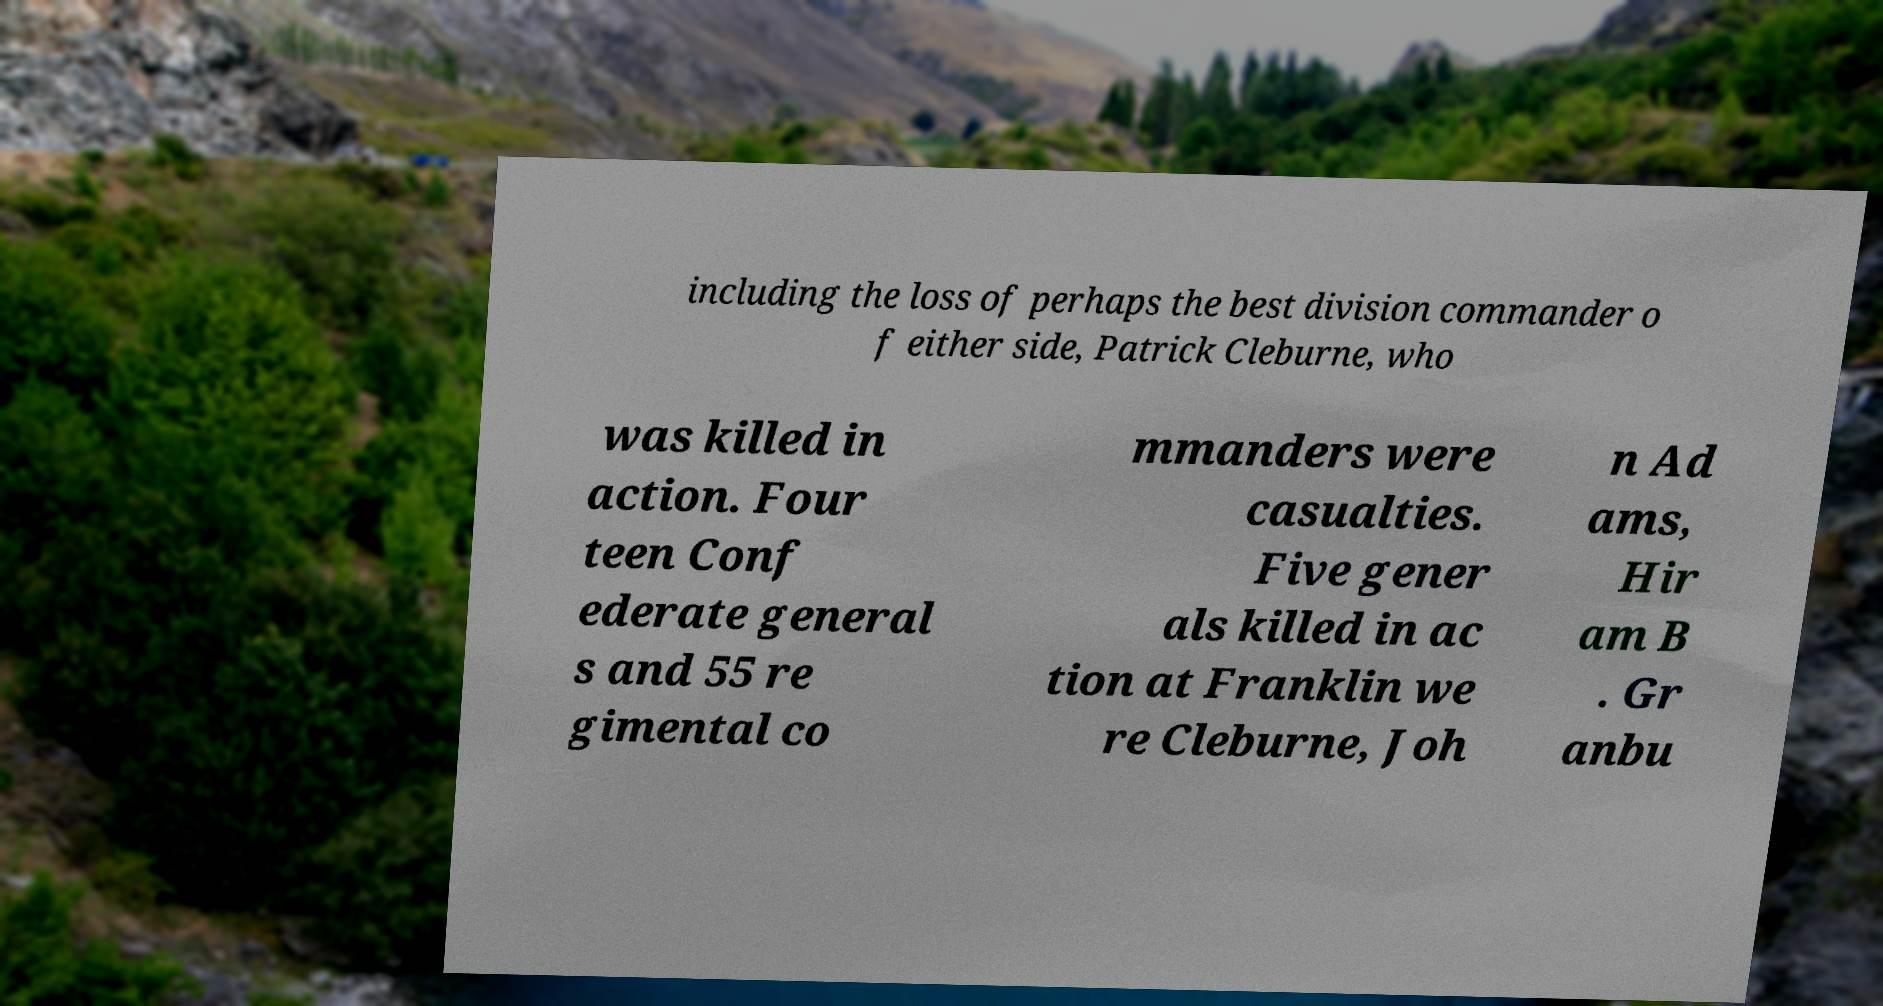Could you extract and type out the text from this image? including the loss of perhaps the best division commander o f either side, Patrick Cleburne, who was killed in action. Four teen Conf ederate general s and 55 re gimental co mmanders were casualties. Five gener als killed in ac tion at Franklin we re Cleburne, Joh n Ad ams, Hir am B . Gr anbu 